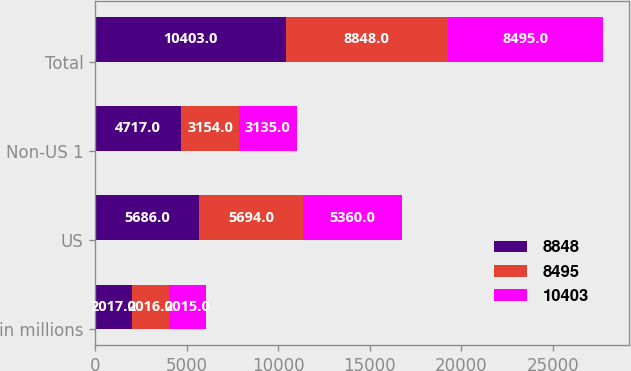Convert chart to OTSL. <chart><loc_0><loc_0><loc_500><loc_500><stacked_bar_chart><ecel><fcel>in millions<fcel>US<fcel>Non-US 1<fcel>Total<nl><fcel>8848<fcel>2017<fcel>5686<fcel>4717<fcel>10403<nl><fcel>8495<fcel>2016<fcel>5694<fcel>3154<fcel>8848<nl><fcel>10403<fcel>2015<fcel>5360<fcel>3135<fcel>8495<nl></chart> 